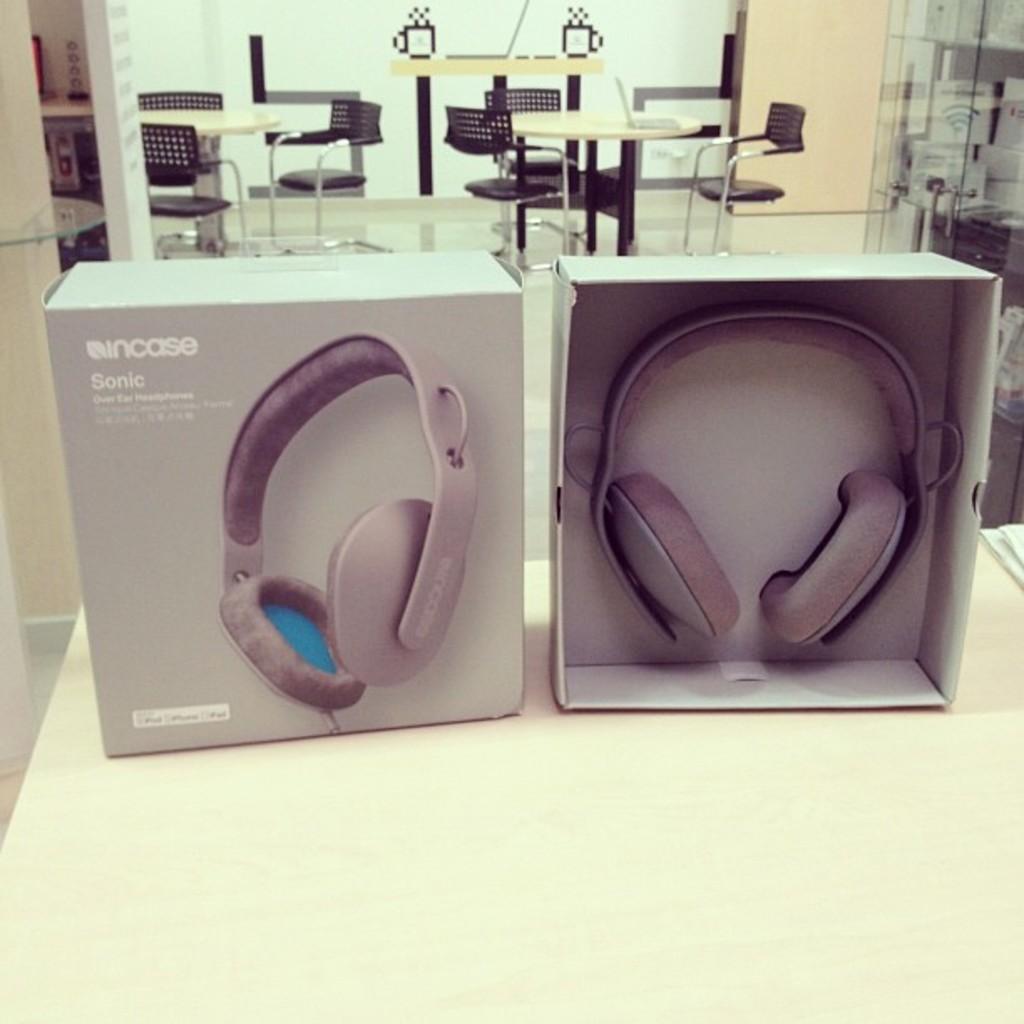Could you give a brief overview of what you see in this image? This picture contains a white table on which box containing headset and an empty headset box are placed. Behind that, there are many tables and chairs. Beside that, we see a cream color wall. On the right corner of the picture, we see a glass door. This picture might be clicked in hotel. 